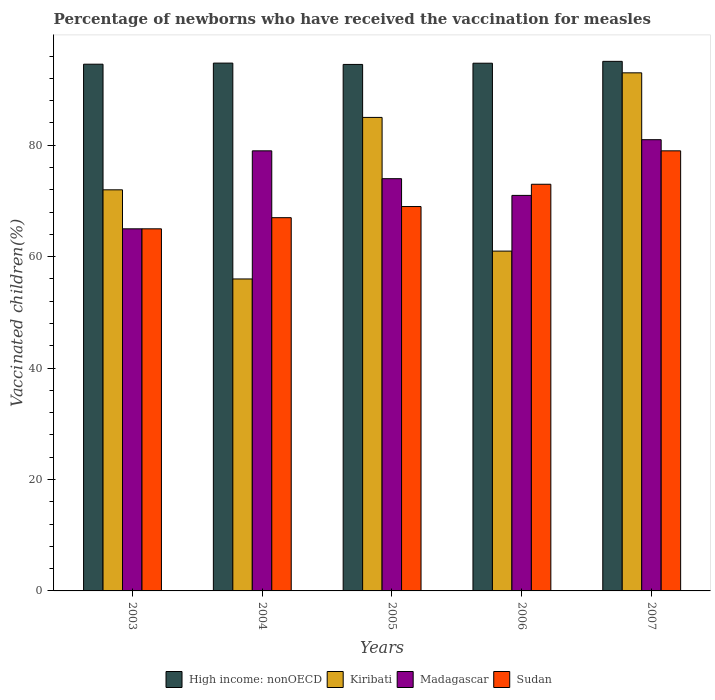How many different coloured bars are there?
Offer a terse response. 4. How many groups of bars are there?
Offer a very short reply. 5. What is the label of the 4th group of bars from the left?
Provide a short and direct response. 2006. Across all years, what is the maximum percentage of vaccinated children in High income: nonOECD?
Make the answer very short. 95.06. In which year was the percentage of vaccinated children in High income: nonOECD minimum?
Your answer should be compact. 2005. What is the total percentage of vaccinated children in Kiribati in the graph?
Make the answer very short. 367. What is the difference between the percentage of vaccinated children in Kiribati in 2006 and the percentage of vaccinated children in Sudan in 2004?
Offer a terse response. -6. What is the average percentage of vaccinated children in Sudan per year?
Provide a succinct answer. 70.6. In the year 2006, what is the difference between the percentage of vaccinated children in High income: nonOECD and percentage of vaccinated children in Sudan?
Ensure brevity in your answer.  21.73. What is the ratio of the percentage of vaccinated children in Sudan in 2005 to that in 2007?
Your answer should be very brief. 0.87. What is the difference between the highest and the second highest percentage of vaccinated children in Madagascar?
Make the answer very short. 2. What is the difference between the highest and the lowest percentage of vaccinated children in Sudan?
Your response must be concise. 14. In how many years, is the percentage of vaccinated children in High income: nonOECD greater than the average percentage of vaccinated children in High income: nonOECD taken over all years?
Provide a short and direct response. 3. Is it the case that in every year, the sum of the percentage of vaccinated children in Madagascar and percentage of vaccinated children in Sudan is greater than the sum of percentage of vaccinated children in Kiribati and percentage of vaccinated children in High income: nonOECD?
Offer a very short reply. No. What does the 1st bar from the left in 2006 represents?
Your answer should be very brief. High income: nonOECD. What does the 2nd bar from the right in 2007 represents?
Keep it short and to the point. Madagascar. Is it the case that in every year, the sum of the percentage of vaccinated children in High income: nonOECD and percentage of vaccinated children in Madagascar is greater than the percentage of vaccinated children in Kiribati?
Provide a succinct answer. Yes. How many years are there in the graph?
Offer a terse response. 5. What is the difference between two consecutive major ticks on the Y-axis?
Offer a terse response. 20. Does the graph contain any zero values?
Provide a short and direct response. No. What is the title of the graph?
Your answer should be compact. Percentage of newborns who have received the vaccination for measles. What is the label or title of the X-axis?
Ensure brevity in your answer.  Years. What is the label or title of the Y-axis?
Your answer should be compact. Vaccinated children(%). What is the Vaccinated children(%) of High income: nonOECD in 2003?
Provide a short and direct response. 94.55. What is the Vaccinated children(%) in Sudan in 2003?
Your response must be concise. 65. What is the Vaccinated children(%) in High income: nonOECD in 2004?
Your answer should be very brief. 94.75. What is the Vaccinated children(%) of Madagascar in 2004?
Your answer should be very brief. 79. What is the Vaccinated children(%) in Sudan in 2004?
Your answer should be compact. 67. What is the Vaccinated children(%) in High income: nonOECD in 2005?
Keep it short and to the point. 94.51. What is the Vaccinated children(%) of Kiribati in 2005?
Offer a very short reply. 85. What is the Vaccinated children(%) of Madagascar in 2005?
Provide a succinct answer. 74. What is the Vaccinated children(%) of High income: nonOECD in 2006?
Your response must be concise. 94.73. What is the Vaccinated children(%) in Kiribati in 2006?
Offer a very short reply. 61. What is the Vaccinated children(%) in High income: nonOECD in 2007?
Ensure brevity in your answer.  95.06. What is the Vaccinated children(%) in Kiribati in 2007?
Provide a short and direct response. 93. What is the Vaccinated children(%) in Sudan in 2007?
Offer a terse response. 79. Across all years, what is the maximum Vaccinated children(%) of High income: nonOECD?
Make the answer very short. 95.06. Across all years, what is the maximum Vaccinated children(%) of Kiribati?
Offer a terse response. 93. Across all years, what is the maximum Vaccinated children(%) of Madagascar?
Provide a succinct answer. 81. Across all years, what is the maximum Vaccinated children(%) of Sudan?
Provide a succinct answer. 79. Across all years, what is the minimum Vaccinated children(%) of High income: nonOECD?
Make the answer very short. 94.51. Across all years, what is the minimum Vaccinated children(%) of Madagascar?
Offer a very short reply. 65. What is the total Vaccinated children(%) in High income: nonOECD in the graph?
Keep it short and to the point. 473.6. What is the total Vaccinated children(%) of Kiribati in the graph?
Give a very brief answer. 367. What is the total Vaccinated children(%) of Madagascar in the graph?
Offer a terse response. 370. What is the total Vaccinated children(%) of Sudan in the graph?
Give a very brief answer. 353. What is the difference between the Vaccinated children(%) of High income: nonOECD in 2003 and that in 2004?
Provide a succinct answer. -0.2. What is the difference between the Vaccinated children(%) in Madagascar in 2003 and that in 2004?
Provide a short and direct response. -14. What is the difference between the Vaccinated children(%) of Sudan in 2003 and that in 2004?
Provide a succinct answer. -2. What is the difference between the Vaccinated children(%) in High income: nonOECD in 2003 and that in 2005?
Make the answer very short. 0.04. What is the difference between the Vaccinated children(%) in Kiribati in 2003 and that in 2005?
Provide a short and direct response. -13. What is the difference between the Vaccinated children(%) in High income: nonOECD in 2003 and that in 2006?
Your answer should be very brief. -0.17. What is the difference between the Vaccinated children(%) of Madagascar in 2003 and that in 2006?
Ensure brevity in your answer.  -6. What is the difference between the Vaccinated children(%) in High income: nonOECD in 2003 and that in 2007?
Offer a terse response. -0.51. What is the difference between the Vaccinated children(%) of Madagascar in 2003 and that in 2007?
Make the answer very short. -16. What is the difference between the Vaccinated children(%) in Sudan in 2003 and that in 2007?
Ensure brevity in your answer.  -14. What is the difference between the Vaccinated children(%) in High income: nonOECD in 2004 and that in 2005?
Give a very brief answer. 0.24. What is the difference between the Vaccinated children(%) of Kiribati in 2004 and that in 2005?
Offer a very short reply. -29. What is the difference between the Vaccinated children(%) in Sudan in 2004 and that in 2005?
Provide a short and direct response. -2. What is the difference between the Vaccinated children(%) in High income: nonOECD in 2004 and that in 2006?
Make the answer very short. 0.02. What is the difference between the Vaccinated children(%) in Kiribati in 2004 and that in 2006?
Offer a very short reply. -5. What is the difference between the Vaccinated children(%) in High income: nonOECD in 2004 and that in 2007?
Offer a terse response. -0.31. What is the difference between the Vaccinated children(%) in Kiribati in 2004 and that in 2007?
Offer a terse response. -37. What is the difference between the Vaccinated children(%) in Madagascar in 2004 and that in 2007?
Ensure brevity in your answer.  -2. What is the difference between the Vaccinated children(%) in High income: nonOECD in 2005 and that in 2006?
Offer a very short reply. -0.22. What is the difference between the Vaccinated children(%) in Madagascar in 2005 and that in 2006?
Provide a succinct answer. 3. What is the difference between the Vaccinated children(%) in High income: nonOECD in 2005 and that in 2007?
Make the answer very short. -0.55. What is the difference between the Vaccinated children(%) of Kiribati in 2005 and that in 2007?
Keep it short and to the point. -8. What is the difference between the Vaccinated children(%) in High income: nonOECD in 2006 and that in 2007?
Provide a short and direct response. -0.33. What is the difference between the Vaccinated children(%) in Kiribati in 2006 and that in 2007?
Give a very brief answer. -32. What is the difference between the Vaccinated children(%) of Madagascar in 2006 and that in 2007?
Your answer should be compact. -10. What is the difference between the Vaccinated children(%) in High income: nonOECD in 2003 and the Vaccinated children(%) in Kiribati in 2004?
Make the answer very short. 38.55. What is the difference between the Vaccinated children(%) in High income: nonOECD in 2003 and the Vaccinated children(%) in Madagascar in 2004?
Offer a terse response. 15.55. What is the difference between the Vaccinated children(%) of High income: nonOECD in 2003 and the Vaccinated children(%) of Sudan in 2004?
Keep it short and to the point. 27.55. What is the difference between the Vaccinated children(%) in Kiribati in 2003 and the Vaccinated children(%) in Madagascar in 2004?
Offer a terse response. -7. What is the difference between the Vaccinated children(%) of Madagascar in 2003 and the Vaccinated children(%) of Sudan in 2004?
Offer a terse response. -2. What is the difference between the Vaccinated children(%) in High income: nonOECD in 2003 and the Vaccinated children(%) in Kiribati in 2005?
Ensure brevity in your answer.  9.55. What is the difference between the Vaccinated children(%) in High income: nonOECD in 2003 and the Vaccinated children(%) in Madagascar in 2005?
Make the answer very short. 20.55. What is the difference between the Vaccinated children(%) of High income: nonOECD in 2003 and the Vaccinated children(%) of Sudan in 2005?
Offer a very short reply. 25.55. What is the difference between the Vaccinated children(%) in Kiribati in 2003 and the Vaccinated children(%) in Madagascar in 2005?
Offer a terse response. -2. What is the difference between the Vaccinated children(%) in High income: nonOECD in 2003 and the Vaccinated children(%) in Kiribati in 2006?
Offer a terse response. 33.55. What is the difference between the Vaccinated children(%) of High income: nonOECD in 2003 and the Vaccinated children(%) of Madagascar in 2006?
Keep it short and to the point. 23.55. What is the difference between the Vaccinated children(%) of High income: nonOECD in 2003 and the Vaccinated children(%) of Sudan in 2006?
Offer a very short reply. 21.55. What is the difference between the Vaccinated children(%) in Madagascar in 2003 and the Vaccinated children(%) in Sudan in 2006?
Offer a terse response. -8. What is the difference between the Vaccinated children(%) of High income: nonOECD in 2003 and the Vaccinated children(%) of Kiribati in 2007?
Offer a very short reply. 1.55. What is the difference between the Vaccinated children(%) in High income: nonOECD in 2003 and the Vaccinated children(%) in Madagascar in 2007?
Provide a short and direct response. 13.55. What is the difference between the Vaccinated children(%) in High income: nonOECD in 2003 and the Vaccinated children(%) in Sudan in 2007?
Your answer should be compact. 15.55. What is the difference between the Vaccinated children(%) in Kiribati in 2003 and the Vaccinated children(%) in Madagascar in 2007?
Make the answer very short. -9. What is the difference between the Vaccinated children(%) of Madagascar in 2003 and the Vaccinated children(%) of Sudan in 2007?
Your answer should be very brief. -14. What is the difference between the Vaccinated children(%) of High income: nonOECD in 2004 and the Vaccinated children(%) of Kiribati in 2005?
Your answer should be very brief. 9.75. What is the difference between the Vaccinated children(%) in High income: nonOECD in 2004 and the Vaccinated children(%) in Madagascar in 2005?
Give a very brief answer. 20.75. What is the difference between the Vaccinated children(%) of High income: nonOECD in 2004 and the Vaccinated children(%) of Sudan in 2005?
Your answer should be very brief. 25.75. What is the difference between the Vaccinated children(%) in Kiribati in 2004 and the Vaccinated children(%) in Madagascar in 2005?
Offer a terse response. -18. What is the difference between the Vaccinated children(%) of High income: nonOECD in 2004 and the Vaccinated children(%) of Kiribati in 2006?
Give a very brief answer. 33.75. What is the difference between the Vaccinated children(%) in High income: nonOECD in 2004 and the Vaccinated children(%) in Madagascar in 2006?
Offer a very short reply. 23.75. What is the difference between the Vaccinated children(%) of High income: nonOECD in 2004 and the Vaccinated children(%) of Sudan in 2006?
Ensure brevity in your answer.  21.75. What is the difference between the Vaccinated children(%) in Kiribati in 2004 and the Vaccinated children(%) in Madagascar in 2006?
Offer a very short reply. -15. What is the difference between the Vaccinated children(%) of Kiribati in 2004 and the Vaccinated children(%) of Sudan in 2006?
Provide a short and direct response. -17. What is the difference between the Vaccinated children(%) in High income: nonOECD in 2004 and the Vaccinated children(%) in Kiribati in 2007?
Provide a short and direct response. 1.75. What is the difference between the Vaccinated children(%) of High income: nonOECD in 2004 and the Vaccinated children(%) of Madagascar in 2007?
Your response must be concise. 13.75. What is the difference between the Vaccinated children(%) in High income: nonOECD in 2004 and the Vaccinated children(%) in Sudan in 2007?
Make the answer very short. 15.75. What is the difference between the Vaccinated children(%) of Kiribati in 2004 and the Vaccinated children(%) of Madagascar in 2007?
Offer a very short reply. -25. What is the difference between the Vaccinated children(%) of Kiribati in 2004 and the Vaccinated children(%) of Sudan in 2007?
Give a very brief answer. -23. What is the difference between the Vaccinated children(%) of High income: nonOECD in 2005 and the Vaccinated children(%) of Kiribati in 2006?
Offer a very short reply. 33.51. What is the difference between the Vaccinated children(%) of High income: nonOECD in 2005 and the Vaccinated children(%) of Madagascar in 2006?
Your answer should be very brief. 23.51. What is the difference between the Vaccinated children(%) in High income: nonOECD in 2005 and the Vaccinated children(%) in Sudan in 2006?
Offer a very short reply. 21.51. What is the difference between the Vaccinated children(%) of Kiribati in 2005 and the Vaccinated children(%) of Sudan in 2006?
Your response must be concise. 12. What is the difference between the Vaccinated children(%) of Madagascar in 2005 and the Vaccinated children(%) of Sudan in 2006?
Give a very brief answer. 1. What is the difference between the Vaccinated children(%) in High income: nonOECD in 2005 and the Vaccinated children(%) in Kiribati in 2007?
Offer a terse response. 1.51. What is the difference between the Vaccinated children(%) in High income: nonOECD in 2005 and the Vaccinated children(%) in Madagascar in 2007?
Your answer should be compact. 13.51. What is the difference between the Vaccinated children(%) of High income: nonOECD in 2005 and the Vaccinated children(%) of Sudan in 2007?
Give a very brief answer. 15.51. What is the difference between the Vaccinated children(%) of Madagascar in 2005 and the Vaccinated children(%) of Sudan in 2007?
Give a very brief answer. -5. What is the difference between the Vaccinated children(%) in High income: nonOECD in 2006 and the Vaccinated children(%) in Kiribati in 2007?
Make the answer very short. 1.73. What is the difference between the Vaccinated children(%) of High income: nonOECD in 2006 and the Vaccinated children(%) of Madagascar in 2007?
Keep it short and to the point. 13.73. What is the difference between the Vaccinated children(%) of High income: nonOECD in 2006 and the Vaccinated children(%) of Sudan in 2007?
Offer a very short reply. 15.73. What is the difference between the Vaccinated children(%) in Kiribati in 2006 and the Vaccinated children(%) in Madagascar in 2007?
Offer a terse response. -20. What is the difference between the Vaccinated children(%) in Kiribati in 2006 and the Vaccinated children(%) in Sudan in 2007?
Provide a succinct answer. -18. What is the average Vaccinated children(%) of High income: nonOECD per year?
Keep it short and to the point. 94.72. What is the average Vaccinated children(%) in Kiribati per year?
Ensure brevity in your answer.  73.4. What is the average Vaccinated children(%) in Madagascar per year?
Provide a short and direct response. 74. What is the average Vaccinated children(%) of Sudan per year?
Your answer should be compact. 70.6. In the year 2003, what is the difference between the Vaccinated children(%) of High income: nonOECD and Vaccinated children(%) of Kiribati?
Make the answer very short. 22.55. In the year 2003, what is the difference between the Vaccinated children(%) in High income: nonOECD and Vaccinated children(%) in Madagascar?
Offer a terse response. 29.55. In the year 2003, what is the difference between the Vaccinated children(%) of High income: nonOECD and Vaccinated children(%) of Sudan?
Your answer should be compact. 29.55. In the year 2003, what is the difference between the Vaccinated children(%) in Kiribati and Vaccinated children(%) in Madagascar?
Your answer should be compact. 7. In the year 2003, what is the difference between the Vaccinated children(%) in Kiribati and Vaccinated children(%) in Sudan?
Provide a succinct answer. 7. In the year 2004, what is the difference between the Vaccinated children(%) in High income: nonOECD and Vaccinated children(%) in Kiribati?
Your response must be concise. 38.75. In the year 2004, what is the difference between the Vaccinated children(%) in High income: nonOECD and Vaccinated children(%) in Madagascar?
Your answer should be compact. 15.75. In the year 2004, what is the difference between the Vaccinated children(%) of High income: nonOECD and Vaccinated children(%) of Sudan?
Ensure brevity in your answer.  27.75. In the year 2004, what is the difference between the Vaccinated children(%) of Kiribati and Vaccinated children(%) of Madagascar?
Give a very brief answer. -23. In the year 2004, what is the difference between the Vaccinated children(%) in Kiribati and Vaccinated children(%) in Sudan?
Your answer should be very brief. -11. In the year 2004, what is the difference between the Vaccinated children(%) of Madagascar and Vaccinated children(%) of Sudan?
Your answer should be compact. 12. In the year 2005, what is the difference between the Vaccinated children(%) in High income: nonOECD and Vaccinated children(%) in Kiribati?
Give a very brief answer. 9.51. In the year 2005, what is the difference between the Vaccinated children(%) in High income: nonOECD and Vaccinated children(%) in Madagascar?
Provide a succinct answer. 20.51. In the year 2005, what is the difference between the Vaccinated children(%) in High income: nonOECD and Vaccinated children(%) in Sudan?
Your answer should be compact. 25.51. In the year 2005, what is the difference between the Vaccinated children(%) in Kiribati and Vaccinated children(%) in Sudan?
Your response must be concise. 16. In the year 2006, what is the difference between the Vaccinated children(%) in High income: nonOECD and Vaccinated children(%) in Kiribati?
Offer a very short reply. 33.73. In the year 2006, what is the difference between the Vaccinated children(%) in High income: nonOECD and Vaccinated children(%) in Madagascar?
Your answer should be compact. 23.73. In the year 2006, what is the difference between the Vaccinated children(%) in High income: nonOECD and Vaccinated children(%) in Sudan?
Keep it short and to the point. 21.73. In the year 2007, what is the difference between the Vaccinated children(%) of High income: nonOECD and Vaccinated children(%) of Kiribati?
Keep it short and to the point. 2.06. In the year 2007, what is the difference between the Vaccinated children(%) in High income: nonOECD and Vaccinated children(%) in Madagascar?
Give a very brief answer. 14.06. In the year 2007, what is the difference between the Vaccinated children(%) of High income: nonOECD and Vaccinated children(%) of Sudan?
Your response must be concise. 16.06. In the year 2007, what is the difference between the Vaccinated children(%) of Kiribati and Vaccinated children(%) of Madagascar?
Ensure brevity in your answer.  12. In the year 2007, what is the difference between the Vaccinated children(%) in Kiribati and Vaccinated children(%) in Sudan?
Your answer should be compact. 14. What is the ratio of the Vaccinated children(%) in High income: nonOECD in 2003 to that in 2004?
Provide a short and direct response. 1. What is the ratio of the Vaccinated children(%) in Kiribati in 2003 to that in 2004?
Make the answer very short. 1.29. What is the ratio of the Vaccinated children(%) in Madagascar in 2003 to that in 2004?
Offer a terse response. 0.82. What is the ratio of the Vaccinated children(%) of Sudan in 2003 to that in 2004?
Provide a succinct answer. 0.97. What is the ratio of the Vaccinated children(%) in High income: nonOECD in 2003 to that in 2005?
Make the answer very short. 1. What is the ratio of the Vaccinated children(%) of Kiribati in 2003 to that in 2005?
Provide a succinct answer. 0.85. What is the ratio of the Vaccinated children(%) of Madagascar in 2003 to that in 2005?
Ensure brevity in your answer.  0.88. What is the ratio of the Vaccinated children(%) of Sudan in 2003 to that in 2005?
Provide a short and direct response. 0.94. What is the ratio of the Vaccinated children(%) in Kiribati in 2003 to that in 2006?
Provide a succinct answer. 1.18. What is the ratio of the Vaccinated children(%) of Madagascar in 2003 to that in 2006?
Your answer should be very brief. 0.92. What is the ratio of the Vaccinated children(%) of Sudan in 2003 to that in 2006?
Provide a short and direct response. 0.89. What is the ratio of the Vaccinated children(%) in Kiribati in 2003 to that in 2007?
Your response must be concise. 0.77. What is the ratio of the Vaccinated children(%) of Madagascar in 2003 to that in 2007?
Make the answer very short. 0.8. What is the ratio of the Vaccinated children(%) of Sudan in 2003 to that in 2007?
Offer a very short reply. 0.82. What is the ratio of the Vaccinated children(%) in Kiribati in 2004 to that in 2005?
Keep it short and to the point. 0.66. What is the ratio of the Vaccinated children(%) of Madagascar in 2004 to that in 2005?
Your response must be concise. 1.07. What is the ratio of the Vaccinated children(%) of Sudan in 2004 to that in 2005?
Give a very brief answer. 0.97. What is the ratio of the Vaccinated children(%) of Kiribati in 2004 to that in 2006?
Provide a short and direct response. 0.92. What is the ratio of the Vaccinated children(%) in Madagascar in 2004 to that in 2006?
Make the answer very short. 1.11. What is the ratio of the Vaccinated children(%) of Sudan in 2004 to that in 2006?
Offer a terse response. 0.92. What is the ratio of the Vaccinated children(%) in Kiribati in 2004 to that in 2007?
Ensure brevity in your answer.  0.6. What is the ratio of the Vaccinated children(%) of Madagascar in 2004 to that in 2007?
Make the answer very short. 0.98. What is the ratio of the Vaccinated children(%) of Sudan in 2004 to that in 2007?
Provide a short and direct response. 0.85. What is the ratio of the Vaccinated children(%) in High income: nonOECD in 2005 to that in 2006?
Keep it short and to the point. 1. What is the ratio of the Vaccinated children(%) of Kiribati in 2005 to that in 2006?
Provide a short and direct response. 1.39. What is the ratio of the Vaccinated children(%) in Madagascar in 2005 to that in 2006?
Your answer should be compact. 1.04. What is the ratio of the Vaccinated children(%) of Sudan in 2005 to that in 2006?
Offer a very short reply. 0.95. What is the ratio of the Vaccinated children(%) in Kiribati in 2005 to that in 2007?
Your response must be concise. 0.91. What is the ratio of the Vaccinated children(%) of Madagascar in 2005 to that in 2007?
Ensure brevity in your answer.  0.91. What is the ratio of the Vaccinated children(%) of Sudan in 2005 to that in 2007?
Keep it short and to the point. 0.87. What is the ratio of the Vaccinated children(%) of Kiribati in 2006 to that in 2007?
Provide a succinct answer. 0.66. What is the ratio of the Vaccinated children(%) in Madagascar in 2006 to that in 2007?
Provide a short and direct response. 0.88. What is the ratio of the Vaccinated children(%) of Sudan in 2006 to that in 2007?
Your answer should be very brief. 0.92. What is the difference between the highest and the second highest Vaccinated children(%) of High income: nonOECD?
Your answer should be very brief. 0.31. What is the difference between the highest and the second highest Vaccinated children(%) of Sudan?
Provide a short and direct response. 6. What is the difference between the highest and the lowest Vaccinated children(%) of High income: nonOECD?
Give a very brief answer. 0.55. What is the difference between the highest and the lowest Vaccinated children(%) in Kiribati?
Make the answer very short. 37. What is the difference between the highest and the lowest Vaccinated children(%) in Madagascar?
Provide a succinct answer. 16. What is the difference between the highest and the lowest Vaccinated children(%) of Sudan?
Keep it short and to the point. 14. 